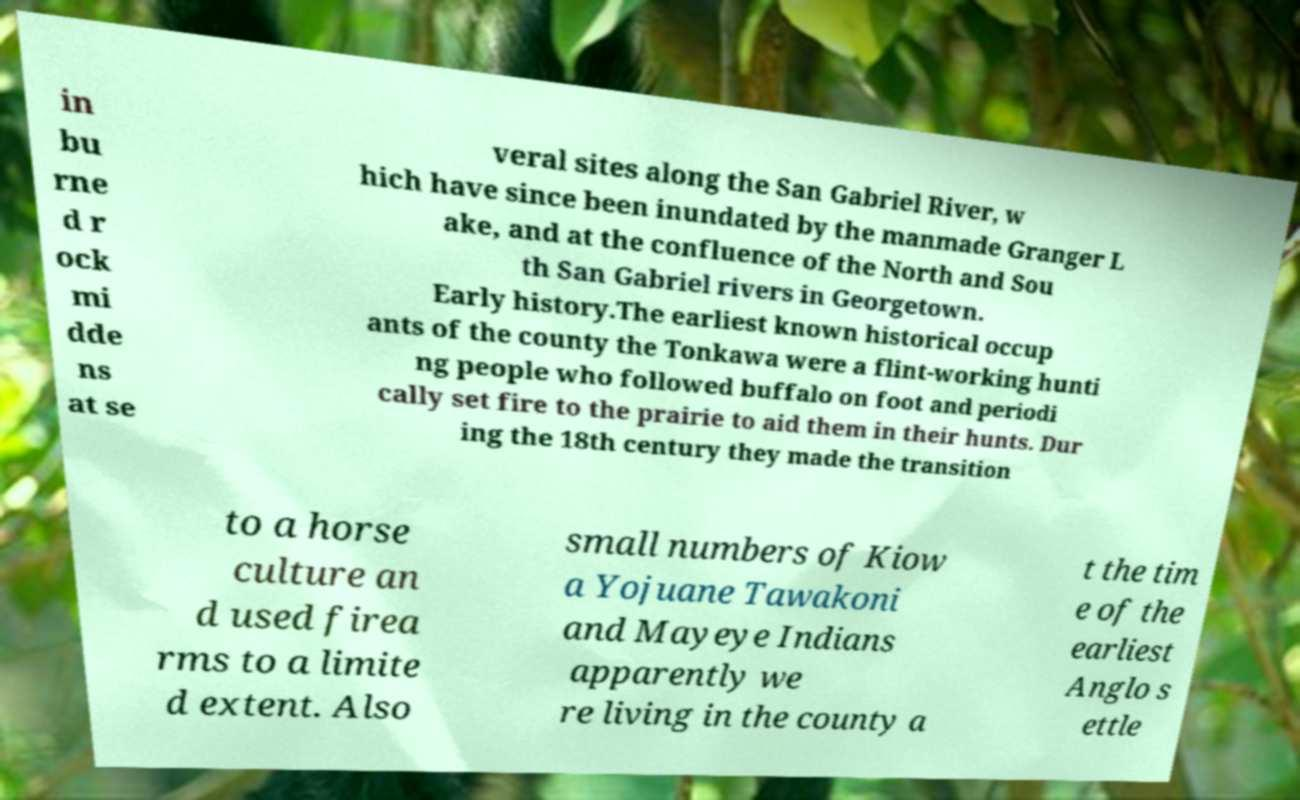What messages or text are displayed in this image? I need them in a readable, typed format. in bu rne d r ock mi dde ns at se veral sites along the San Gabriel River, w hich have since been inundated by the manmade Granger L ake, and at the confluence of the North and Sou th San Gabriel rivers in Georgetown. Early history.The earliest known historical occup ants of the county the Tonkawa were a flint-working hunti ng people who followed buffalo on foot and periodi cally set fire to the prairie to aid them in their hunts. Dur ing the 18th century they made the transition to a horse culture an d used firea rms to a limite d extent. Also small numbers of Kiow a Yojuane Tawakoni and Mayeye Indians apparently we re living in the county a t the tim e of the earliest Anglo s ettle 